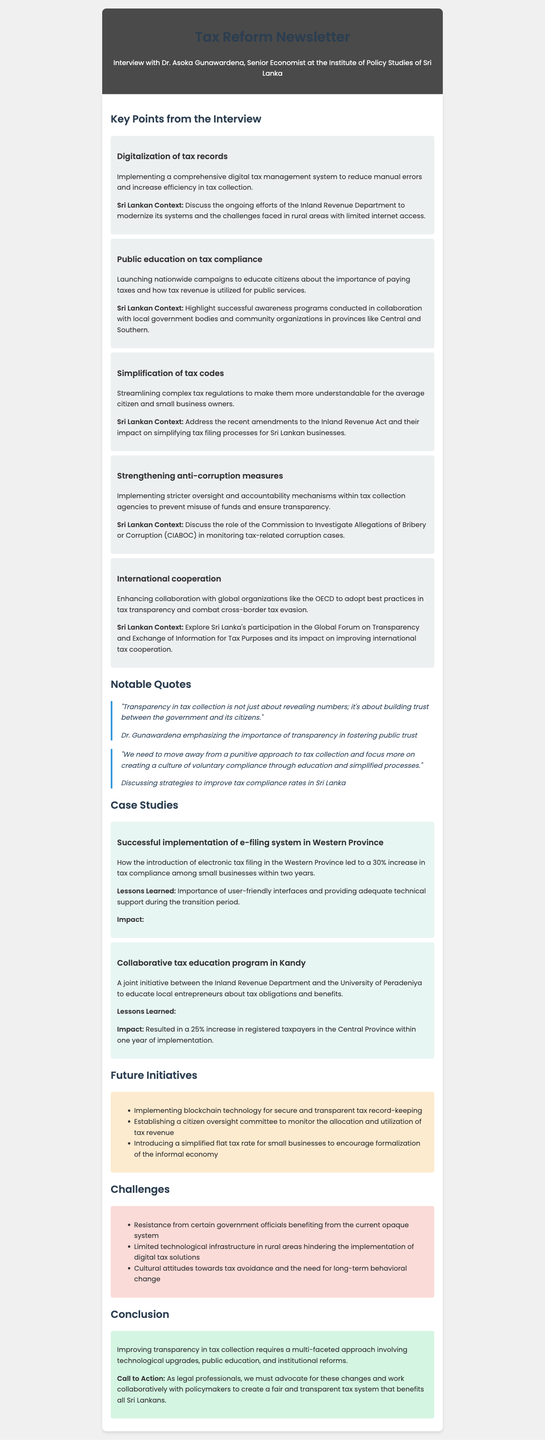What is the position of the interviewee? The position of Dr. Asoka Gunawardena is mentioned in the document as Senior Economist at the Institute of Policy Studies of Sri Lanka.
Answer: Senior Economist What percentage increase in tax compliance was reported in the Western Province case study? The document states that there was a 30% increase in tax compliance among small businesses in the Western Province.
Answer: 30% Which global organization is mentioned for enhancing international cooperation on tax transparency? The document references the OECD as a global organization for adopting best practices in tax transparency.
Answer: OECD What is one future initiative mentioned for improving tax record-keeping? The document lists implementing blockchain technology for secure and transparent tax record-keeping as a future initiative.
Answer: Blockchain technology What was the impact of the collaborative tax education program in Kandy? The document specifies that the collaborative tax education program in Kandy resulted in a 25% increase in registered taxpayers in the Central Province.
Answer: 25% increase What is one challenge faced in implementing digital tax solutions? The document identifies limited technological infrastructure in rural areas as a challenge in implementing digital tax solutions.
Answer: Limited technological infrastructure What is emphasized as key to building trust between the government and citizens? The document quotes Dr. Gunawardena stating that transparency in tax collection is essential to build trust with citizens.
Answer: Transparency What is the call to action for legal professionals as stated in the conclusion? The document encourages legal professionals to advocate for changes to create a fair and transparent tax system.
Answer: Advocate for changes 